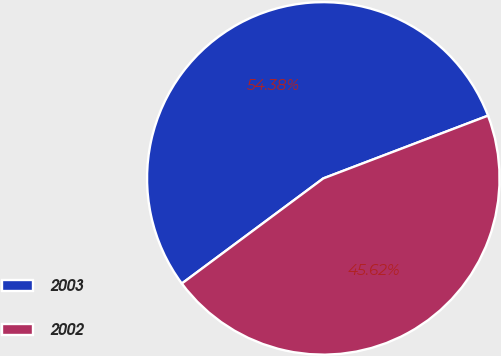<chart> <loc_0><loc_0><loc_500><loc_500><pie_chart><fcel>2003<fcel>2002<nl><fcel>54.38%<fcel>45.62%<nl></chart> 